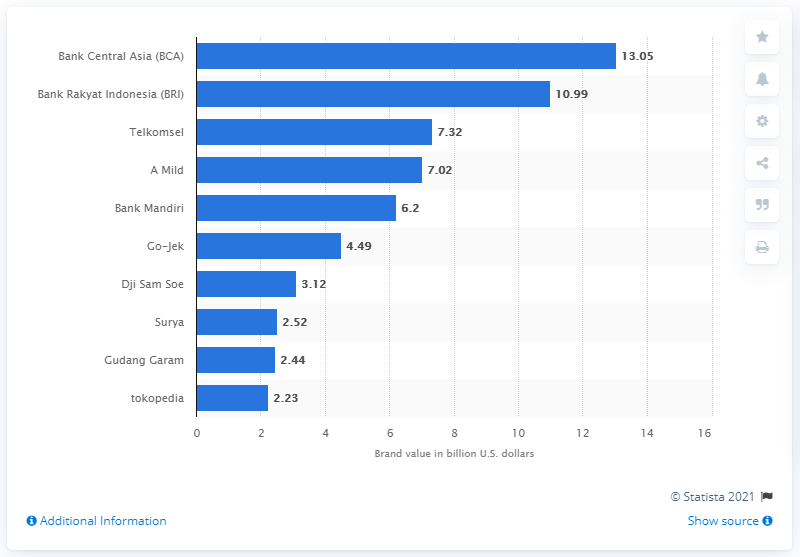Apart from financial services, what other industries are represented in this chart? Besides financial services, there are brands from various other industries represented in this chart, including telecommunications with Telkomsel, consumer goods with A Mild and Surya for cigarettes, technology with Go-Jek and Tokopedia, and one more from the tobacco industry, Gudang Garam. 